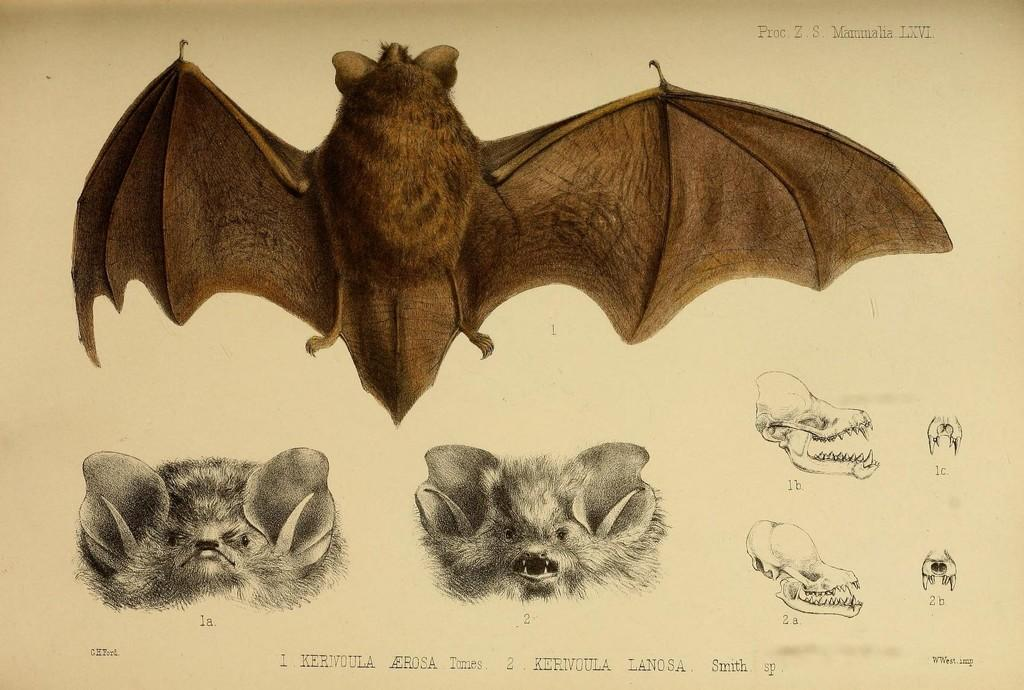What is the medium of the image? The image is on a paper. What type of animals are depicted in the drawings on the paper? The drawings include bats. What specific features of the bats are included in the drawings? The drawings include bat claws and a bat skull. What can be found at the bottom of the paper? There is text at the bottom of the paper. What type of apparel is being worn by the bats in the image? There is no apparel depicted on the bats in the image; they are drawn as animals without clothing. 